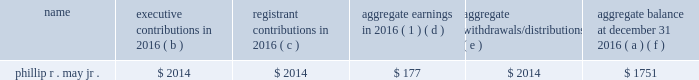2016 non-qualified deferred compensation as of december 31 , 2016 , mr .
May had a deferred account balance under a frozen defined contribution restoration plan .
The amount is deemed invested , as chosen by the participant , in certain t .
Rowe price investment funds that are also available to the participant under the savings plan .
Mr .
May has elected to receive the deferred account balance after he retires .
The defined contribution restoration plan , until it was frozen in 2005 , credited eligible employees 2019 deferral accounts with employer contributions to the extent contributions under the qualified savings plan in which the employee participated were subject to limitations imposed by the code .
Defined contribution restoration plan executive contributions in registrant contributions in aggregate earnings in 2016 ( 1 ) aggregate withdrawals/ distributions aggregate balance at december 31 , ( a ) ( b ) ( c ) ( d ) ( e ) ( f ) .
( 1 ) amounts in this column are not included in the summary compensation table .
2016 potential payments upon termination or change in control entergy corporation has plans and other arrangements that provide compensation to a named executive officer if his or her employment terminates under specified conditions , including following a change in control of entergy corporation .
In addition , in 2006 entergy corporation entered into a retention agreement with mr .
Denault that provides possibility of additional service credit under the system executive retirement plan upon certain terminations of employment .
There are no plans or agreements that would provide for payments to any of the named executive officers solely upon a change in control .
The tables below reflect the amount of compensation each of the named executive officers would have received if his or her employment with their entergy employer had been terminated under various scenarios as of december 31 , 2016 .
For purposes of these tables , a stock price of $ 73.47 was used , which was the closing market price on december 30 , 2016 , the last trading day of the year. .
Baaed on the table , how many shares does in the plan does mr . may have based of the closing stock price of $ 73.47 as of december 30 , 2016? 
Computations: (1751 / 73.47)
Answer: 23.83286. 2016 non-qualified deferred compensation as of december 31 , 2016 , mr .
May had a deferred account balance under a frozen defined contribution restoration plan .
The amount is deemed invested , as chosen by the participant , in certain t .
Rowe price investment funds that are also available to the participant under the savings plan .
Mr .
May has elected to receive the deferred account balance after he retires .
The defined contribution restoration plan , until it was frozen in 2005 , credited eligible employees 2019 deferral accounts with employer contributions to the extent contributions under the qualified savings plan in which the employee participated were subject to limitations imposed by the code .
Defined contribution restoration plan executive contributions in registrant contributions in aggregate earnings in 2016 ( 1 ) aggregate withdrawals/ distributions aggregate balance at december 31 , ( a ) ( b ) ( c ) ( d ) ( e ) ( f ) .
( 1 ) amounts in this column are not included in the summary compensation table .
2016 potential payments upon termination or change in control entergy corporation has plans and other arrangements that provide compensation to a named executive officer if his or her employment terminates under specified conditions , including following a change in control of entergy corporation .
In addition , in 2006 entergy corporation entered into a retention agreement with mr .
Denault that provides possibility of additional service credit under the system executive retirement plan upon certain terminations of employment .
There are no plans or agreements that would provide for payments to any of the named executive officers solely upon a change in control .
The tables below reflect the amount of compensation each of the named executive officers would have received if his or her employment with their entergy employer had been terminated under various scenarios as of december 31 , 2016 .
For purposes of these tables , a stock price of $ 73.47 was used , which was the closing market price on december 30 , 2016 , the last trading day of the year. .
What was mr . may's 12/31/15 plan balance? 
Computations: (1751 + 177)
Answer: 1928.0. 